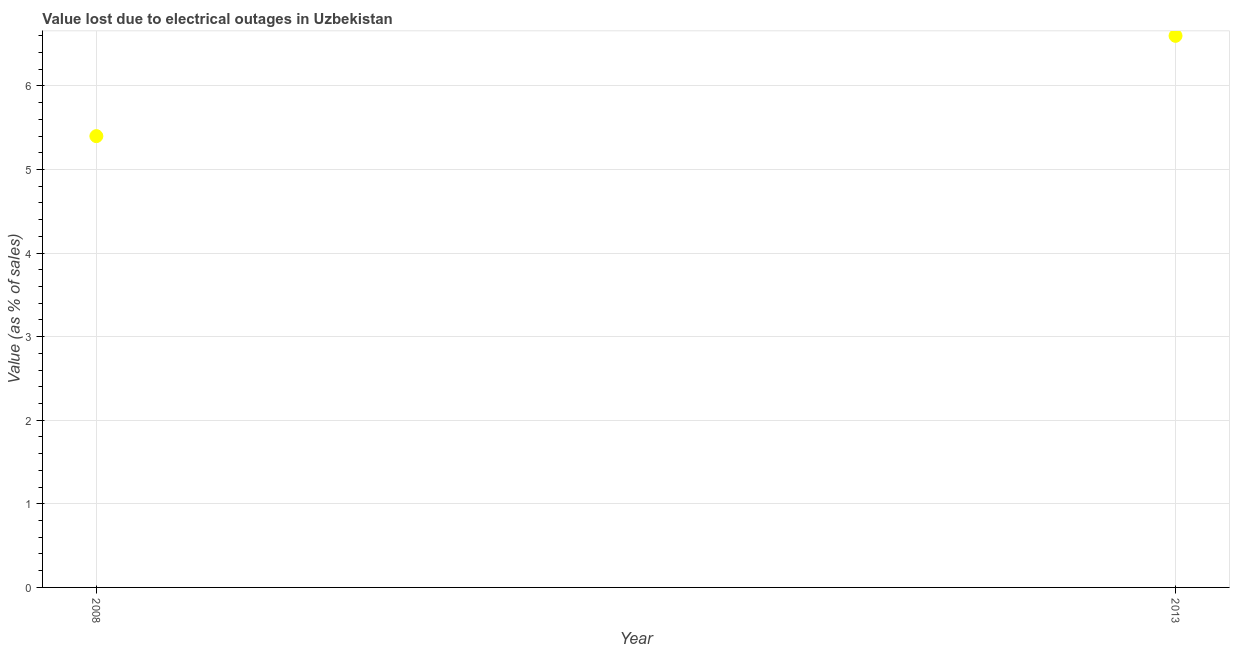What is the value lost due to electrical outages in 2013?
Your response must be concise. 6.6. In which year was the value lost due to electrical outages maximum?
Give a very brief answer. 2013. What is the sum of the value lost due to electrical outages?
Ensure brevity in your answer.  12. What is the difference between the value lost due to electrical outages in 2008 and 2013?
Offer a very short reply. -1.2. What is the average value lost due to electrical outages per year?
Give a very brief answer. 6. What is the median value lost due to electrical outages?
Keep it short and to the point. 6. In how many years, is the value lost due to electrical outages greater than 1.4 %?
Give a very brief answer. 2. What is the ratio of the value lost due to electrical outages in 2008 to that in 2013?
Offer a terse response. 0.82. In how many years, is the value lost due to electrical outages greater than the average value lost due to electrical outages taken over all years?
Your answer should be compact. 1. How many dotlines are there?
Offer a very short reply. 1. How many years are there in the graph?
Offer a terse response. 2. Are the values on the major ticks of Y-axis written in scientific E-notation?
Your response must be concise. No. Does the graph contain grids?
Make the answer very short. Yes. What is the title of the graph?
Your answer should be compact. Value lost due to electrical outages in Uzbekistan. What is the label or title of the X-axis?
Offer a very short reply. Year. What is the label or title of the Y-axis?
Offer a very short reply. Value (as % of sales). What is the Value (as % of sales) in 2008?
Your answer should be very brief. 5.4. What is the ratio of the Value (as % of sales) in 2008 to that in 2013?
Your answer should be compact. 0.82. 